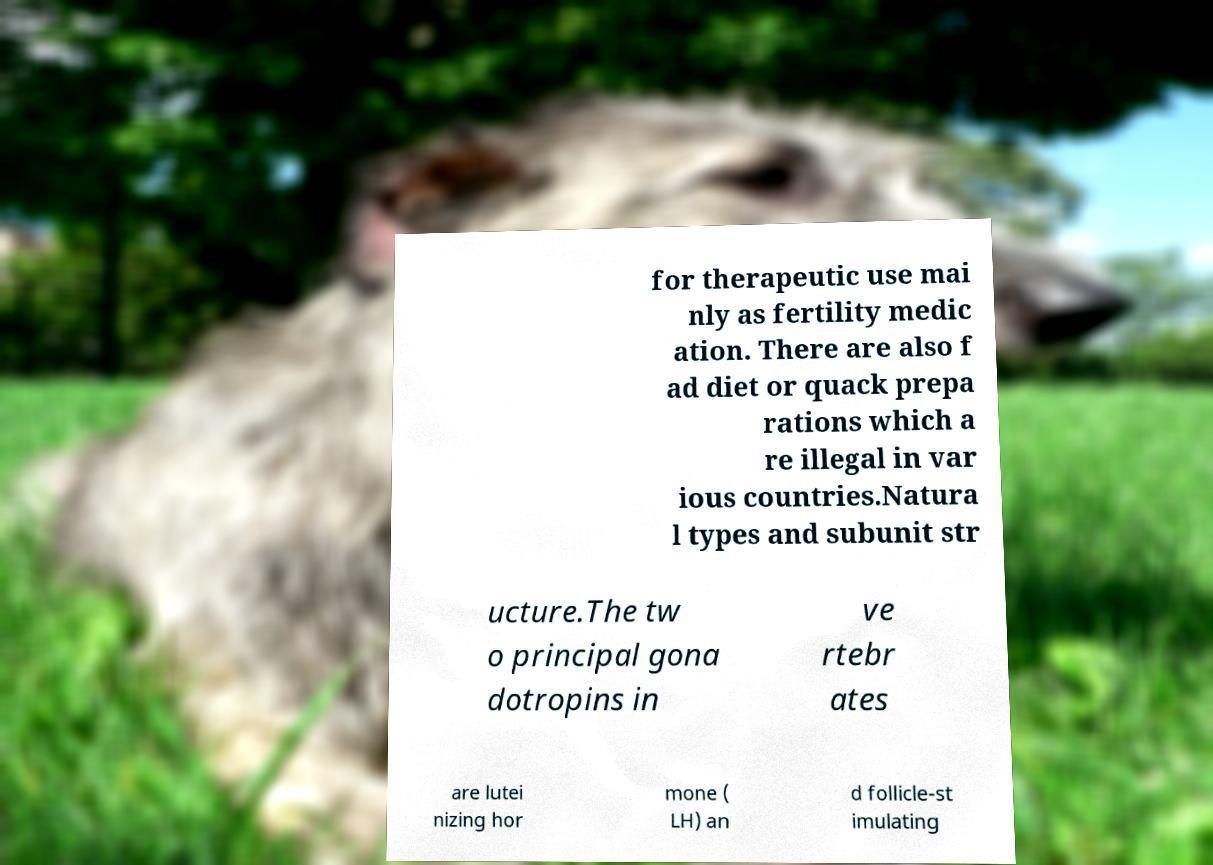Please identify and transcribe the text found in this image. for therapeutic use mai nly as fertility medic ation. There are also f ad diet or quack prepa rations which a re illegal in var ious countries.Natura l types and subunit str ucture.The tw o principal gona dotropins in ve rtebr ates are lutei nizing hor mone ( LH) an d follicle-st imulating 